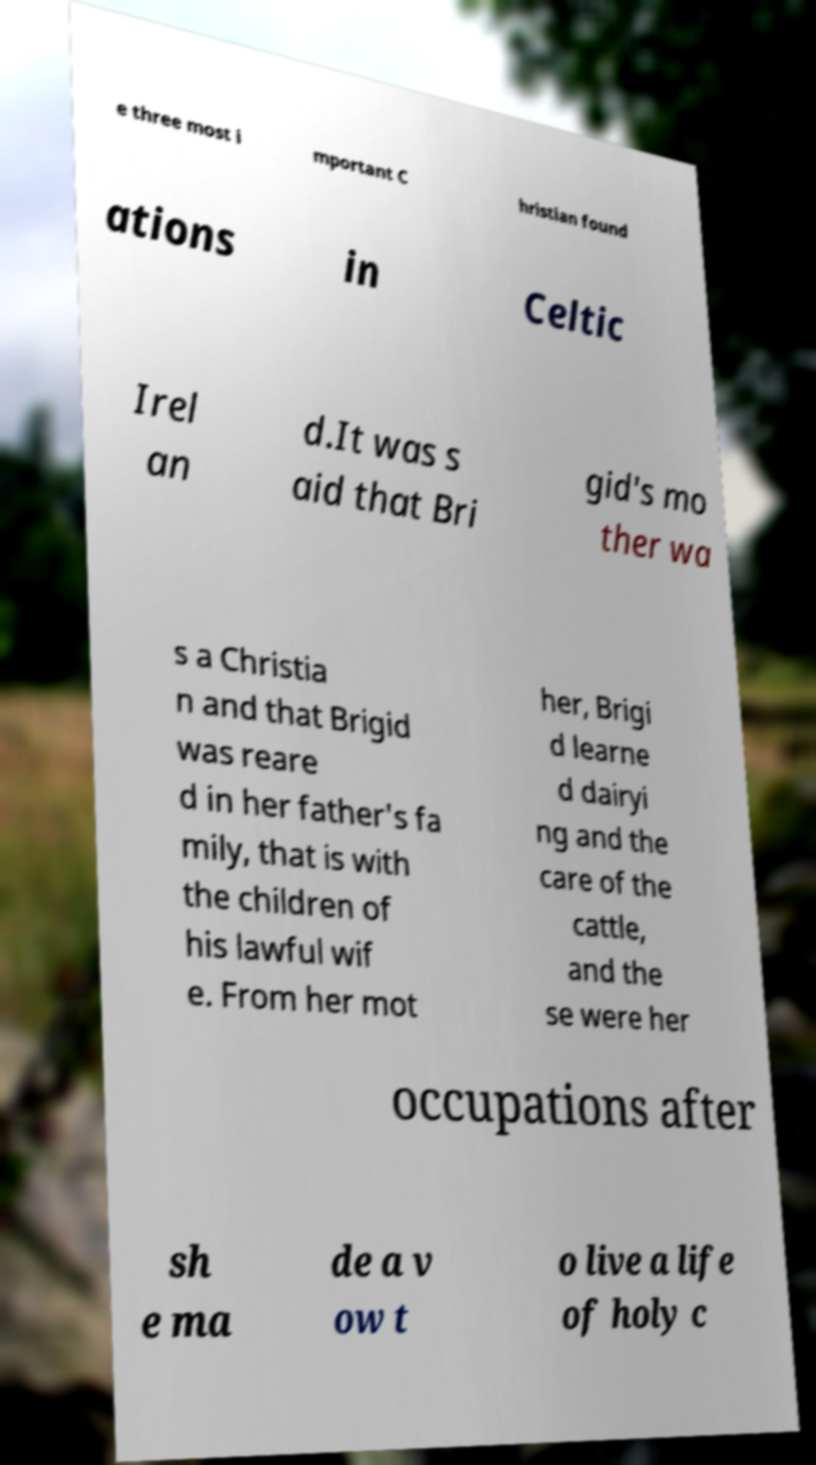Please read and relay the text visible in this image. What does it say? e three most i mportant C hristian found ations in Celtic Irel an d.It was s aid that Bri gid's mo ther wa s a Christia n and that Brigid was reare d in her father's fa mily, that is with the children of his lawful wif e. From her mot her, Brigi d learne d dairyi ng and the care of the cattle, and the se were her occupations after sh e ma de a v ow t o live a life of holy c 